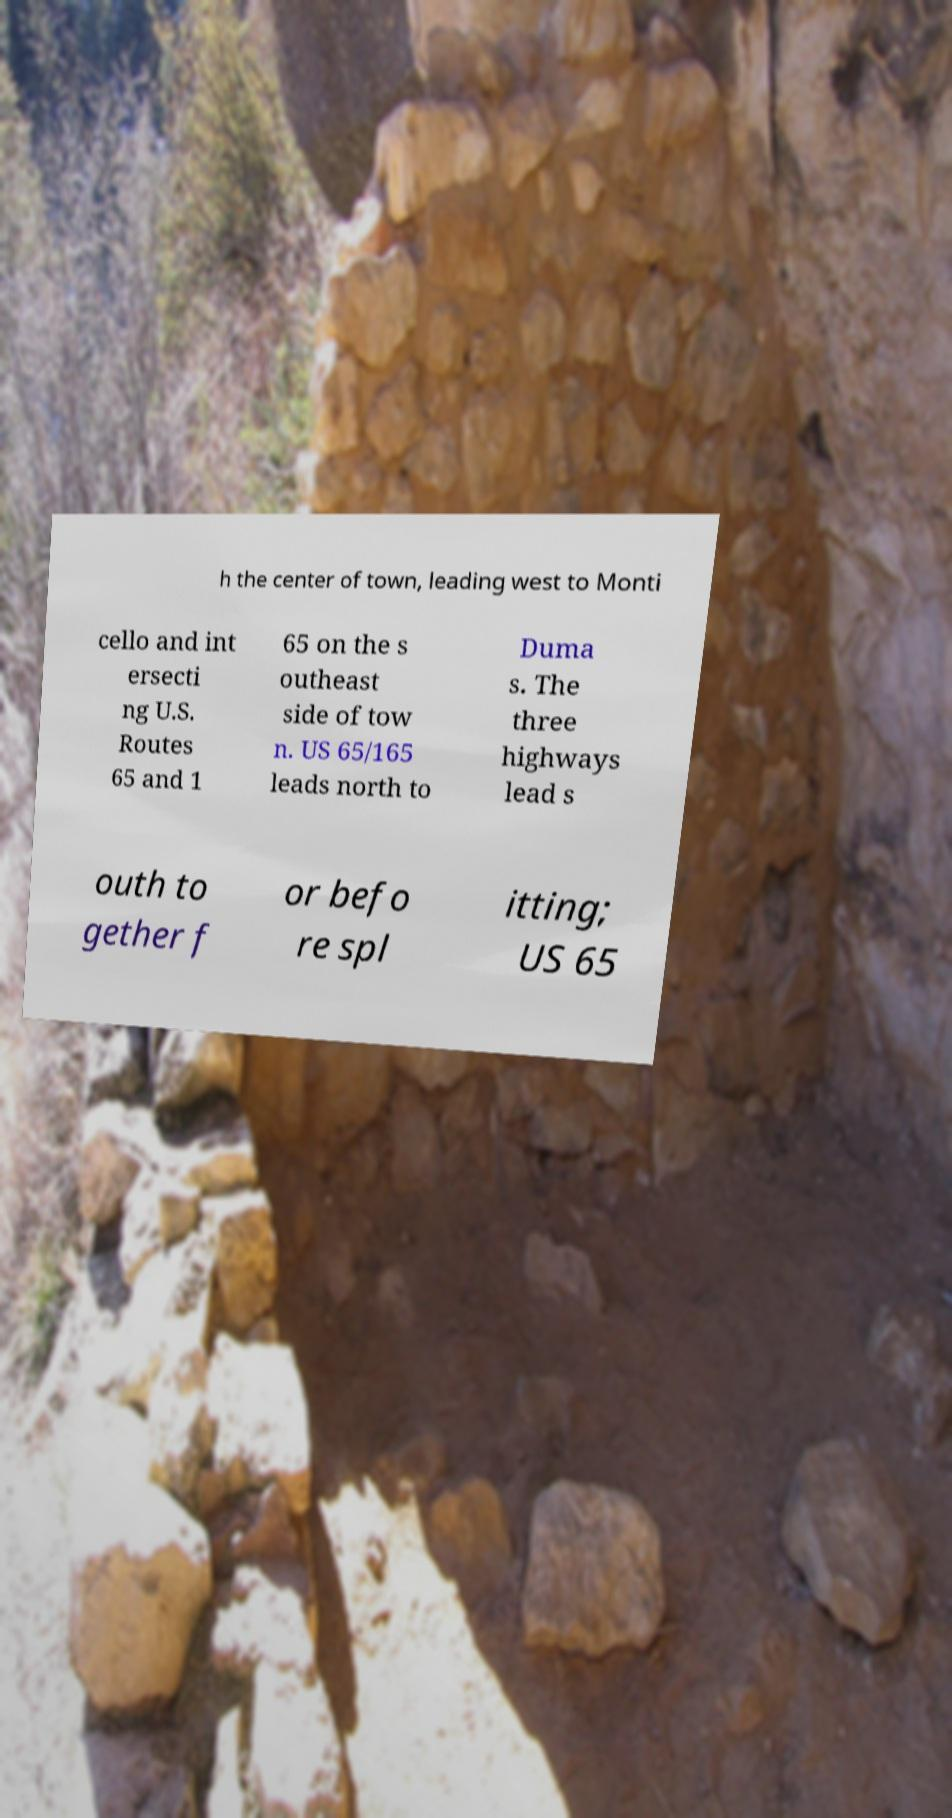I need the written content from this picture converted into text. Can you do that? h the center of town, leading west to Monti cello and int ersecti ng U.S. Routes 65 and 1 65 on the s outheast side of tow n. US 65/165 leads north to Duma s. The three highways lead s outh to gether f or befo re spl itting; US 65 